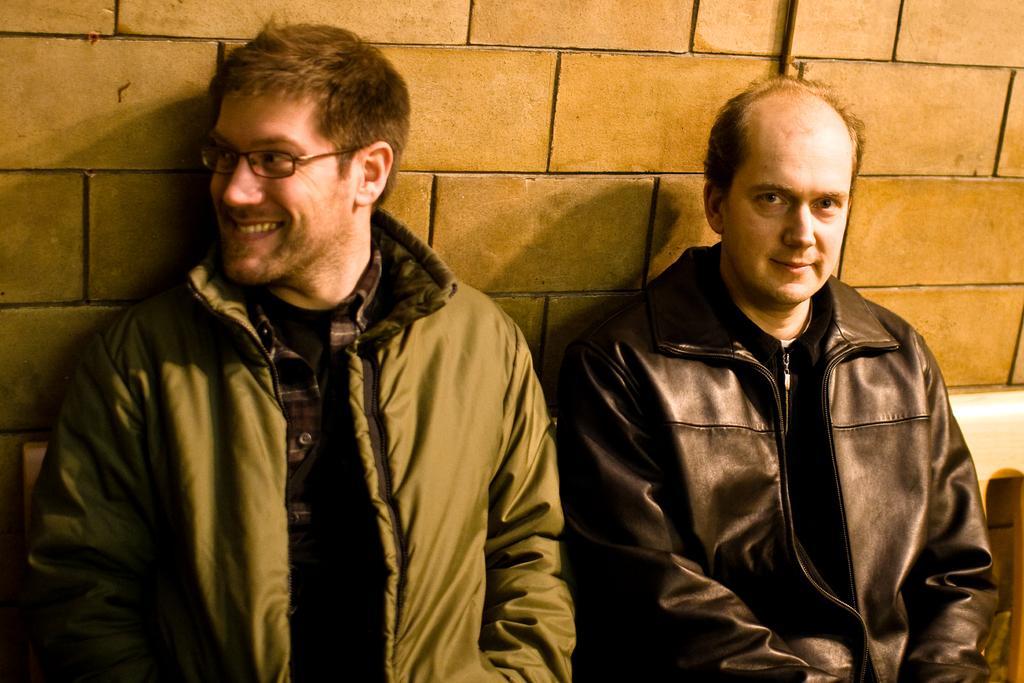How would you summarize this image in a sentence or two? In this picture there are two men in the center of the image and there is a wall in the background area of the image. 